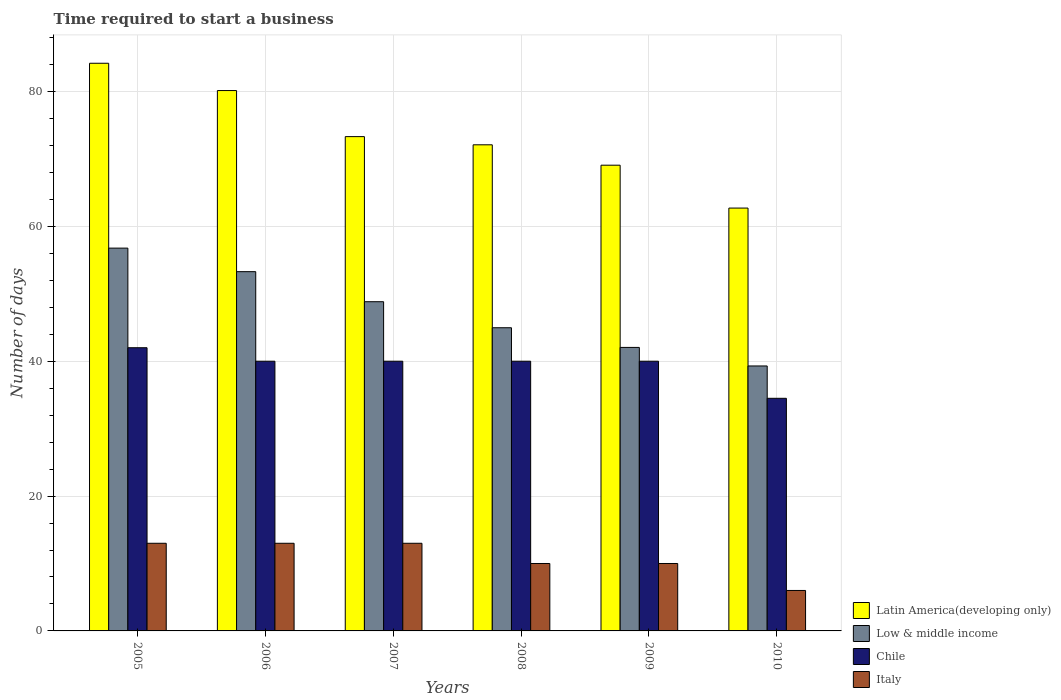Are the number of bars on each tick of the X-axis equal?
Provide a short and direct response. Yes. How many bars are there on the 3rd tick from the left?
Keep it short and to the point. 4. How many bars are there on the 3rd tick from the right?
Give a very brief answer. 4. What is the number of days required to start a business in Latin America(developing only) in 2010?
Offer a terse response. 62.71. Across all years, what is the maximum number of days required to start a business in Low & middle income?
Offer a very short reply. 56.77. Across all years, what is the minimum number of days required to start a business in Latin America(developing only)?
Your answer should be very brief. 62.71. In which year was the number of days required to start a business in Italy maximum?
Give a very brief answer. 2005. What is the total number of days required to start a business in Low & middle income in the graph?
Provide a short and direct response. 285.19. What is the difference between the number of days required to start a business in Low & middle income in 2005 and that in 2010?
Ensure brevity in your answer.  17.48. What is the difference between the number of days required to start a business in Italy in 2007 and the number of days required to start a business in Latin America(developing only) in 2010?
Make the answer very short. -49.71. What is the average number of days required to start a business in Italy per year?
Offer a terse response. 10.83. In the year 2006, what is the difference between the number of days required to start a business in Latin America(developing only) and number of days required to start a business in Low & middle income?
Your response must be concise. 26.86. What is the ratio of the number of days required to start a business in Chile in 2006 to that in 2009?
Make the answer very short. 1. Is the number of days required to start a business in Latin America(developing only) in 2007 less than that in 2009?
Give a very brief answer. No. What is the difference between the highest and the second highest number of days required to start a business in Chile?
Make the answer very short. 2. Is the sum of the number of days required to start a business in Chile in 2009 and 2010 greater than the maximum number of days required to start a business in Low & middle income across all years?
Ensure brevity in your answer.  Yes. Is it the case that in every year, the sum of the number of days required to start a business in Latin America(developing only) and number of days required to start a business in Low & middle income is greater than the sum of number of days required to start a business in Italy and number of days required to start a business in Chile?
Keep it short and to the point. Yes. What does the 3rd bar from the left in 2005 represents?
Offer a terse response. Chile. Is it the case that in every year, the sum of the number of days required to start a business in Chile and number of days required to start a business in Low & middle income is greater than the number of days required to start a business in Italy?
Provide a succinct answer. Yes. How many bars are there?
Provide a short and direct response. 24. Are all the bars in the graph horizontal?
Your answer should be compact. No. How many years are there in the graph?
Keep it short and to the point. 6. Where does the legend appear in the graph?
Provide a short and direct response. Bottom right. What is the title of the graph?
Give a very brief answer. Time required to start a business. Does "Malta" appear as one of the legend labels in the graph?
Keep it short and to the point. No. What is the label or title of the Y-axis?
Give a very brief answer. Number of days. What is the Number of days in Latin America(developing only) in 2005?
Ensure brevity in your answer.  84.19. What is the Number of days of Low & middle income in 2005?
Make the answer very short. 56.77. What is the Number of days in Italy in 2005?
Your response must be concise. 13. What is the Number of days in Latin America(developing only) in 2006?
Your answer should be very brief. 80.14. What is the Number of days of Low & middle income in 2006?
Make the answer very short. 53.28. What is the Number of days of Chile in 2006?
Your answer should be compact. 40. What is the Number of days of Latin America(developing only) in 2007?
Offer a very short reply. 73.31. What is the Number of days of Low & middle income in 2007?
Your answer should be compact. 48.82. What is the Number of days of Italy in 2007?
Ensure brevity in your answer.  13. What is the Number of days of Latin America(developing only) in 2008?
Your answer should be very brief. 72.1. What is the Number of days of Low & middle income in 2008?
Offer a very short reply. 44.97. What is the Number of days in Italy in 2008?
Your response must be concise. 10. What is the Number of days in Latin America(developing only) in 2009?
Keep it short and to the point. 69.07. What is the Number of days in Low & middle income in 2009?
Offer a very short reply. 42.05. What is the Number of days of Italy in 2009?
Provide a succinct answer. 10. What is the Number of days in Latin America(developing only) in 2010?
Offer a terse response. 62.71. What is the Number of days in Low & middle income in 2010?
Offer a terse response. 39.3. What is the Number of days of Chile in 2010?
Provide a short and direct response. 34.5. Across all years, what is the maximum Number of days in Latin America(developing only)?
Keep it short and to the point. 84.19. Across all years, what is the maximum Number of days in Low & middle income?
Your answer should be compact. 56.77. Across all years, what is the maximum Number of days of Chile?
Provide a short and direct response. 42. Across all years, what is the minimum Number of days of Latin America(developing only)?
Offer a very short reply. 62.71. Across all years, what is the minimum Number of days of Low & middle income?
Your response must be concise. 39.3. Across all years, what is the minimum Number of days in Chile?
Give a very brief answer. 34.5. What is the total Number of days in Latin America(developing only) in the graph?
Your response must be concise. 441.52. What is the total Number of days in Low & middle income in the graph?
Your answer should be compact. 285.19. What is the total Number of days in Chile in the graph?
Your response must be concise. 236.5. What is the difference between the Number of days of Latin America(developing only) in 2005 and that in 2006?
Your answer should be very brief. 4.05. What is the difference between the Number of days of Low & middle income in 2005 and that in 2006?
Provide a succinct answer. 3.49. What is the difference between the Number of days in Chile in 2005 and that in 2006?
Ensure brevity in your answer.  2. What is the difference between the Number of days of Italy in 2005 and that in 2006?
Offer a very short reply. 0. What is the difference between the Number of days in Latin America(developing only) in 2005 and that in 2007?
Keep it short and to the point. 10.88. What is the difference between the Number of days in Low & middle income in 2005 and that in 2007?
Make the answer very short. 7.95. What is the difference between the Number of days of Italy in 2005 and that in 2007?
Offer a terse response. 0. What is the difference between the Number of days in Latin America(developing only) in 2005 and that in 2008?
Provide a succinct answer. 12.1. What is the difference between the Number of days in Low & middle income in 2005 and that in 2008?
Make the answer very short. 11.81. What is the difference between the Number of days of Italy in 2005 and that in 2008?
Provide a short and direct response. 3. What is the difference between the Number of days of Latin America(developing only) in 2005 and that in 2009?
Make the answer very short. 15.12. What is the difference between the Number of days of Low & middle income in 2005 and that in 2009?
Your response must be concise. 14.73. What is the difference between the Number of days of Chile in 2005 and that in 2009?
Provide a short and direct response. 2. What is the difference between the Number of days of Italy in 2005 and that in 2009?
Provide a short and direct response. 3. What is the difference between the Number of days in Latin America(developing only) in 2005 and that in 2010?
Give a very brief answer. 21.48. What is the difference between the Number of days in Low & middle income in 2005 and that in 2010?
Offer a very short reply. 17.48. What is the difference between the Number of days of Italy in 2005 and that in 2010?
Provide a succinct answer. 7. What is the difference between the Number of days in Latin America(developing only) in 2006 and that in 2007?
Offer a terse response. 6.83. What is the difference between the Number of days of Low & middle income in 2006 and that in 2007?
Ensure brevity in your answer.  4.46. What is the difference between the Number of days in Chile in 2006 and that in 2007?
Your response must be concise. 0. What is the difference between the Number of days in Italy in 2006 and that in 2007?
Keep it short and to the point. 0. What is the difference between the Number of days in Latin America(developing only) in 2006 and that in 2008?
Offer a terse response. 8.05. What is the difference between the Number of days in Low & middle income in 2006 and that in 2008?
Make the answer very short. 8.32. What is the difference between the Number of days of Chile in 2006 and that in 2008?
Provide a succinct answer. 0. What is the difference between the Number of days of Latin America(developing only) in 2006 and that in 2009?
Make the answer very short. 11.07. What is the difference between the Number of days of Low & middle income in 2006 and that in 2009?
Provide a short and direct response. 11.24. What is the difference between the Number of days in Chile in 2006 and that in 2009?
Your answer should be compact. 0. What is the difference between the Number of days of Latin America(developing only) in 2006 and that in 2010?
Provide a short and direct response. 17.43. What is the difference between the Number of days in Low & middle income in 2006 and that in 2010?
Give a very brief answer. 13.99. What is the difference between the Number of days in Chile in 2006 and that in 2010?
Make the answer very short. 5.5. What is the difference between the Number of days in Italy in 2006 and that in 2010?
Your response must be concise. 7. What is the difference between the Number of days in Latin America(developing only) in 2007 and that in 2008?
Provide a succinct answer. 1.21. What is the difference between the Number of days of Low & middle income in 2007 and that in 2008?
Your answer should be very brief. 3.86. What is the difference between the Number of days of Italy in 2007 and that in 2008?
Your answer should be compact. 3. What is the difference between the Number of days of Latin America(developing only) in 2007 and that in 2009?
Your response must be concise. 4.24. What is the difference between the Number of days in Low & middle income in 2007 and that in 2009?
Ensure brevity in your answer.  6.78. What is the difference between the Number of days of Chile in 2007 and that in 2009?
Provide a succinct answer. 0. What is the difference between the Number of days of Italy in 2007 and that in 2009?
Offer a terse response. 3. What is the difference between the Number of days in Latin America(developing only) in 2007 and that in 2010?
Offer a very short reply. 10.6. What is the difference between the Number of days of Low & middle income in 2007 and that in 2010?
Your answer should be compact. 9.53. What is the difference between the Number of days of Italy in 2007 and that in 2010?
Your answer should be very brief. 7. What is the difference between the Number of days in Latin America(developing only) in 2008 and that in 2009?
Your response must be concise. 3.02. What is the difference between the Number of days of Low & middle income in 2008 and that in 2009?
Your response must be concise. 2.92. What is the difference between the Number of days of Latin America(developing only) in 2008 and that in 2010?
Your answer should be compact. 9.38. What is the difference between the Number of days in Low & middle income in 2008 and that in 2010?
Offer a very short reply. 5.67. What is the difference between the Number of days of Italy in 2008 and that in 2010?
Offer a very short reply. 4. What is the difference between the Number of days of Latin America(developing only) in 2009 and that in 2010?
Make the answer very short. 6.36. What is the difference between the Number of days of Low & middle income in 2009 and that in 2010?
Offer a very short reply. 2.75. What is the difference between the Number of days in Chile in 2009 and that in 2010?
Provide a succinct answer. 5.5. What is the difference between the Number of days of Latin America(developing only) in 2005 and the Number of days of Low & middle income in 2006?
Your answer should be very brief. 30.91. What is the difference between the Number of days of Latin America(developing only) in 2005 and the Number of days of Chile in 2006?
Keep it short and to the point. 44.19. What is the difference between the Number of days of Latin America(developing only) in 2005 and the Number of days of Italy in 2006?
Your answer should be compact. 71.19. What is the difference between the Number of days in Low & middle income in 2005 and the Number of days in Chile in 2006?
Your answer should be compact. 16.77. What is the difference between the Number of days in Low & middle income in 2005 and the Number of days in Italy in 2006?
Your response must be concise. 43.77. What is the difference between the Number of days in Chile in 2005 and the Number of days in Italy in 2006?
Your response must be concise. 29. What is the difference between the Number of days of Latin America(developing only) in 2005 and the Number of days of Low & middle income in 2007?
Keep it short and to the point. 35.37. What is the difference between the Number of days in Latin America(developing only) in 2005 and the Number of days in Chile in 2007?
Provide a succinct answer. 44.19. What is the difference between the Number of days of Latin America(developing only) in 2005 and the Number of days of Italy in 2007?
Make the answer very short. 71.19. What is the difference between the Number of days in Low & middle income in 2005 and the Number of days in Chile in 2007?
Offer a terse response. 16.77. What is the difference between the Number of days in Low & middle income in 2005 and the Number of days in Italy in 2007?
Offer a very short reply. 43.77. What is the difference between the Number of days of Chile in 2005 and the Number of days of Italy in 2007?
Offer a terse response. 29. What is the difference between the Number of days in Latin America(developing only) in 2005 and the Number of days in Low & middle income in 2008?
Your answer should be very brief. 39.22. What is the difference between the Number of days in Latin America(developing only) in 2005 and the Number of days in Chile in 2008?
Offer a very short reply. 44.19. What is the difference between the Number of days in Latin America(developing only) in 2005 and the Number of days in Italy in 2008?
Keep it short and to the point. 74.19. What is the difference between the Number of days in Low & middle income in 2005 and the Number of days in Chile in 2008?
Give a very brief answer. 16.77. What is the difference between the Number of days of Low & middle income in 2005 and the Number of days of Italy in 2008?
Your answer should be compact. 46.77. What is the difference between the Number of days in Latin America(developing only) in 2005 and the Number of days in Low & middle income in 2009?
Your answer should be compact. 42.14. What is the difference between the Number of days in Latin America(developing only) in 2005 and the Number of days in Chile in 2009?
Provide a short and direct response. 44.19. What is the difference between the Number of days in Latin America(developing only) in 2005 and the Number of days in Italy in 2009?
Give a very brief answer. 74.19. What is the difference between the Number of days of Low & middle income in 2005 and the Number of days of Chile in 2009?
Your answer should be compact. 16.77. What is the difference between the Number of days of Low & middle income in 2005 and the Number of days of Italy in 2009?
Your answer should be compact. 46.77. What is the difference between the Number of days of Latin America(developing only) in 2005 and the Number of days of Low & middle income in 2010?
Make the answer very short. 44.89. What is the difference between the Number of days of Latin America(developing only) in 2005 and the Number of days of Chile in 2010?
Your answer should be compact. 49.69. What is the difference between the Number of days in Latin America(developing only) in 2005 and the Number of days in Italy in 2010?
Offer a very short reply. 78.19. What is the difference between the Number of days in Low & middle income in 2005 and the Number of days in Chile in 2010?
Make the answer very short. 22.27. What is the difference between the Number of days of Low & middle income in 2005 and the Number of days of Italy in 2010?
Your answer should be very brief. 50.77. What is the difference between the Number of days in Chile in 2005 and the Number of days in Italy in 2010?
Offer a terse response. 36. What is the difference between the Number of days in Latin America(developing only) in 2006 and the Number of days in Low & middle income in 2007?
Offer a very short reply. 31.32. What is the difference between the Number of days in Latin America(developing only) in 2006 and the Number of days in Chile in 2007?
Ensure brevity in your answer.  40.14. What is the difference between the Number of days in Latin America(developing only) in 2006 and the Number of days in Italy in 2007?
Offer a terse response. 67.14. What is the difference between the Number of days in Low & middle income in 2006 and the Number of days in Chile in 2007?
Offer a very short reply. 13.28. What is the difference between the Number of days of Low & middle income in 2006 and the Number of days of Italy in 2007?
Provide a short and direct response. 40.28. What is the difference between the Number of days in Latin America(developing only) in 2006 and the Number of days in Low & middle income in 2008?
Your response must be concise. 35.18. What is the difference between the Number of days in Latin America(developing only) in 2006 and the Number of days in Chile in 2008?
Give a very brief answer. 40.14. What is the difference between the Number of days of Latin America(developing only) in 2006 and the Number of days of Italy in 2008?
Give a very brief answer. 70.14. What is the difference between the Number of days in Low & middle income in 2006 and the Number of days in Chile in 2008?
Provide a short and direct response. 13.28. What is the difference between the Number of days of Low & middle income in 2006 and the Number of days of Italy in 2008?
Provide a succinct answer. 43.28. What is the difference between the Number of days of Latin America(developing only) in 2006 and the Number of days of Low & middle income in 2009?
Ensure brevity in your answer.  38.1. What is the difference between the Number of days of Latin America(developing only) in 2006 and the Number of days of Chile in 2009?
Provide a succinct answer. 40.14. What is the difference between the Number of days of Latin America(developing only) in 2006 and the Number of days of Italy in 2009?
Your answer should be compact. 70.14. What is the difference between the Number of days in Low & middle income in 2006 and the Number of days in Chile in 2009?
Ensure brevity in your answer.  13.28. What is the difference between the Number of days of Low & middle income in 2006 and the Number of days of Italy in 2009?
Ensure brevity in your answer.  43.28. What is the difference between the Number of days of Chile in 2006 and the Number of days of Italy in 2009?
Offer a terse response. 30. What is the difference between the Number of days in Latin America(developing only) in 2006 and the Number of days in Low & middle income in 2010?
Provide a succinct answer. 40.85. What is the difference between the Number of days in Latin America(developing only) in 2006 and the Number of days in Chile in 2010?
Give a very brief answer. 45.64. What is the difference between the Number of days of Latin America(developing only) in 2006 and the Number of days of Italy in 2010?
Make the answer very short. 74.14. What is the difference between the Number of days in Low & middle income in 2006 and the Number of days in Chile in 2010?
Offer a terse response. 18.78. What is the difference between the Number of days of Low & middle income in 2006 and the Number of days of Italy in 2010?
Offer a terse response. 47.28. What is the difference between the Number of days in Latin America(developing only) in 2007 and the Number of days in Low & middle income in 2008?
Offer a very short reply. 28.34. What is the difference between the Number of days of Latin America(developing only) in 2007 and the Number of days of Chile in 2008?
Provide a succinct answer. 33.31. What is the difference between the Number of days of Latin America(developing only) in 2007 and the Number of days of Italy in 2008?
Keep it short and to the point. 63.31. What is the difference between the Number of days in Low & middle income in 2007 and the Number of days in Chile in 2008?
Keep it short and to the point. 8.82. What is the difference between the Number of days of Low & middle income in 2007 and the Number of days of Italy in 2008?
Your answer should be very brief. 38.82. What is the difference between the Number of days in Latin America(developing only) in 2007 and the Number of days in Low & middle income in 2009?
Your answer should be compact. 31.26. What is the difference between the Number of days of Latin America(developing only) in 2007 and the Number of days of Chile in 2009?
Provide a short and direct response. 33.31. What is the difference between the Number of days of Latin America(developing only) in 2007 and the Number of days of Italy in 2009?
Your response must be concise. 63.31. What is the difference between the Number of days in Low & middle income in 2007 and the Number of days in Chile in 2009?
Offer a terse response. 8.82. What is the difference between the Number of days in Low & middle income in 2007 and the Number of days in Italy in 2009?
Your response must be concise. 38.82. What is the difference between the Number of days of Chile in 2007 and the Number of days of Italy in 2009?
Your response must be concise. 30. What is the difference between the Number of days of Latin America(developing only) in 2007 and the Number of days of Low & middle income in 2010?
Your response must be concise. 34.01. What is the difference between the Number of days of Latin America(developing only) in 2007 and the Number of days of Chile in 2010?
Make the answer very short. 38.81. What is the difference between the Number of days of Latin America(developing only) in 2007 and the Number of days of Italy in 2010?
Provide a short and direct response. 67.31. What is the difference between the Number of days of Low & middle income in 2007 and the Number of days of Chile in 2010?
Your answer should be compact. 14.32. What is the difference between the Number of days in Low & middle income in 2007 and the Number of days in Italy in 2010?
Make the answer very short. 42.82. What is the difference between the Number of days of Latin America(developing only) in 2008 and the Number of days of Low & middle income in 2009?
Make the answer very short. 30.05. What is the difference between the Number of days of Latin America(developing only) in 2008 and the Number of days of Chile in 2009?
Your answer should be compact. 32.1. What is the difference between the Number of days in Latin America(developing only) in 2008 and the Number of days in Italy in 2009?
Your response must be concise. 62.1. What is the difference between the Number of days in Low & middle income in 2008 and the Number of days in Chile in 2009?
Ensure brevity in your answer.  4.97. What is the difference between the Number of days of Low & middle income in 2008 and the Number of days of Italy in 2009?
Make the answer very short. 34.97. What is the difference between the Number of days of Chile in 2008 and the Number of days of Italy in 2009?
Your answer should be compact. 30. What is the difference between the Number of days in Latin America(developing only) in 2008 and the Number of days in Low & middle income in 2010?
Give a very brief answer. 32.8. What is the difference between the Number of days in Latin America(developing only) in 2008 and the Number of days in Chile in 2010?
Offer a very short reply. 37.6. What is the difference between the Number of days in Latin America(developing only) in 2008 and the Number of days in Italy in 2010?
Provide a succinct answer. 66.1. What is the difference between the Number of days of Low & middle income in 2008 and the Number of days of Chile in 2010?
Your response must be concise. 10.47. What is the difference between the Number of days of Low & middle income in 2008 and the Number of days of Italy in 2010?
Ensure brevity in your answer.  38.97. What is the difference between the Number of days in Latin America(developing only) in 2009 and the Number of days in Low & middle income in 2010?
Give a very brief answer. 29.77. What is the difference between the Number of days in Latin America(developing only) in 2009 and the Number of days in Chile in 2010?
Ensure brevity in your answer.  34.57. What is the difference between the Number of days of Latin America(developing only) in 2009 and the Number of days of Italy in 2010?
Give a very brief answer. 63.07. What is the difference between the Number of days in Low & middle income in 2009 and the Number of days in Chile in 2010?
Provide a short and direct response. 7.55. What is the difference between the Number of days of Low & middle income in 2009 and the Number of days of Italy in 2010?
Offer a terse response. 36.05. What is the difference between the Number of days in Chile in 2009 and the Number of days in Italy in 2010?
Make the answer very short. 34. What is the average Number of days of Latin America(developing only) per year?
Your answer should be compact. 73.59. What is the average Number of days of Low & middle income per year?
Your response must be concise. 47.53. What is the average Number of days in Chile per year?
Provide a short and direct response. 39.42. What is the average Number of days of Italy per year?
Provide a short and direct response. 10.83. In the year 2005, what is the difference between the Number of days of Latin America(developing only) and Number of days of Low & middle income?
Your response must be concise. 27.42. In the year 2005, what is the difference between the Number of days in Latin America(developing only) and Number of days in Chile?
Offer a very short reply. 42.19. In the year 2005, what is the difference between the Number of days of Latin America(developing only) and Number of days of Italy?
Offer a terse response. 71.19. In the year 2005, what is the difference between the Number of days of Low & middle income and Number of days of Chile?
Provide a succinct answer. 14.77. In the year 2005, what is the difference between the Number of days in Low & middle income and Number of days in Italy?
Provide a short and direct response. 43.77. In the year 2005, what is the difference between the Number of days in Chile and Number of days in Italy?
Keep it short and to the point. 29. In the year 2006, what is the difference between the Number of days of Latin America(developing only) and Number of days of Low & middle income?
Your answer should be compact. 26.86. In the year 2006, what is the difference between the Number of days of Latin America(developing only) and Number of days of Chile?
Your answer should be very brief. 40.14. In the year 2006, what is the difference between the Number of days of Latin America(developing only) and Number of days of Italy?
Make the answer very short. 67.14. In the year 2006, what is the difference between the Number of days in Low & middle income and Number of days in Chile?
Make the answer very short. 13.28. In the year 2006, what is the difference between the Number of days in Low & middle income and Number of days in Italy?
Offer a very short reply. 40.28. In the year 2007, what is the difference between the Number of days of Latin America(developing only) and Number of days of Low & middle income?
Keep it short and to the point. 24.48. In the year 2007, what is the difference between the Number of days of Latin America(developing only) and Number of days of Chile?
Keep it short and to the point. 33.31. In the year 2007, what is the difference between the Number of days in Latin America(developing only) and Number of days in Italy?
Ensure brevity in your answer.  60.31. In the year 2007, what is the difference between the Number of days in Low & middle income and Number of days in Chile?
Offer a terse response. 8.82. In the year 2007, what is the difference between the Number of days of Low & middle income and Number of days of Italy?
Offer a very short reply. 35.82. In the year 2008, what is the difference between the Number of days of Latin America(developing only) and Number of days of Low & middle income?
Your answer should be very brief. 27.13. In the year 2008, what is the difference between the Number of days in Latin America(developing only) and Number of days in Chile?
Keep it short and to the point. 32.1. In the year 2008, what is the difference between the Number of days of Latin America(developing only) and Number of days of Italy?
Offer a very short reply. 62.1. In the year 2008, what is the difference between the Number of days in Low & middle income and Number of days in Chile?
Offer a terse response. 4.97. In the year 2008, what is the difference between the Number of days in Low & middle income and Number of days in Italy?
Ensure brevity in your answer.  34.97. In the year 2008, what is the difference between the Number of days of Chile and Number of days of Italy?
Give a very brief answer. 30. In the year 2009, what is the difference between the Number of days of Latin America(developing only) and Number of days of Low & middle income?
Ensure brevity in your answer.  27.02. In the year 2009, what is the difference between the Number of days in Latin America(developing only) and Number of days in Chile?
Make the answer very short. 29.07. In the year 2009, what is the difference between the Number of days of Latin America(developing only) and Number of days of Italy?
Give a very brief answer. 59.07. In the year 2009, what is the difference between the Number of days of Low & middle income and Number of days of Chile?
Keep it short and to the point. 2.05. In the year 2009, what is the difference between the Number of days of Low & middle income and Number of days of Italy?
Provide a succinct answer. 32.05. In the year 2009, what is the difference between the Number of days of Chile and Number of days of Italy?
Give a very brief answer. 30. In the year 2010, what is the difference between the Number of days of Latin America(developing only) and Number of days of Low & middle income?
Your answer should be very brief. 23.42. In the year 2010, what is the difference between the Number of days in Latin America(developing only) and Number of days in Chile?
Make the answer very short. 28.21. In the year 2010, what is the difference between the Number of days of Latin America(developing only) and Number of days of Italy?
Provide a succinct answer. 56.71. In the year 2010, what is the difference between the Number of days in Low & middle income and Number of days in Chile?
Your answer should be compact. 4.8. In the year 2010, what is the difference between the Number of days of Low & middle income and Number of days of Italy?
Offer a terse response. 33.3. What is the ratio of the Number of days in Latin America(developing only) in 2005 to that in 2006?
Your answer should be very brief. 1.05. What is the ratio of the Number of days in Low & middle income in 2005 to that in 2006?
Offer a very short reply. 1.07. What is the ratio of the Number of days of Chile in 2005 to that in 2006?
Provide a short and direct response. 1.05. What is the ratio of the Number of days in Latin America(developing only) in 2005 to that in 2007?
Your answer should be compact. 1.15. What is the ratio of the Number of days in Low & middle income in 2005 to that in 2007?
Your response must be concise. 1.16. What is the ratio of the Number of days in Chile in 2005 to that in 2007?
Offer a very short reply. 1.05. What is the ratio of the Number of days in Italy in 2005 to that in 2007?
Offer a terse response. 1. What is the ratio of the Number of days of Latin America(developing only) in 2005 to that in 2008?
Give a very brief answer. 1.17. What is the ratio of the Number of days in Low & middle income in 2005 to that in 2008?
Your answer should be compact. 1.26. What is the ratio of the Number of days in Chile in 2005 to that in 2008?
Provide a succinct answer. 1.05. What is the ratio of the Number of days of Latin America(developing only) in 2005 to that in 2009?
Provide a short and direct response. 1.22. What is the ratio of the Number of days of Low & middle income in 2005 to that in 2009?
Offer a terse response. 1.35. What is the ratio of the Number of days of Italy in 2005 to that in 2009?
Provide a succinct answer. 1.3. What is the ratio of the Number of days in Latin America(developing only) in 2005 to that in 2010?
Your answer should be very brief. 1.34. What is the ratio of the Number of days of Low & middle income in 2005 to that in 2010?
Offer a terse response. 1.44. What is the ratio of the Number of days in Chile in 2005 to that in 2010?
Make the answer very short. 1.22. What is the ratio of the Number of days in Italy in 2005 to that in 2010?
Provide a short and direct response. 2.17. What is the ratio of the Number of days in Latin America(developing only) in 2006 to that in 2007?
Provide a short and direct response. 1.09. What is the ratio of the Number of days of Low & middle income in 2006 to that in 2007?
Your response must be concise. 1.09. What is the ratio of the Number of days of Chile in 2006 to that in 2007?
Your answer should be very brief. 1. What is the ratio of the Number of days in Italy in 2006 to that in 2007?
Make the answer very short. 1. What is the ratio of the Number of days of Latin America(developing only) in 2006 to that in 2008?
Offer a terse response. 1.11. What is the ratio of the Number of days of Low & middle income in 2006 to that in 2008?
Provide a short and direct response. 1.18. What is the ratio of the Number of days in Chile in 2006 to that in 2008?
Provide a short and direct response. 1. What is the ratio of the Number of days in Italy in 2006 to that in 2008?
Your response must be concise. 1.3. What is the ratio of the Number of days of Latin America(developing only) in 2006 to that in 2009?
Ensure brevity in your answer.  1.16. What is the ratio of the Number of days in Low & middle income in 2006 to that in 2009?
Ensure brevity in your answer.  1.27. What is the ratio of the Number of days in Chile in 2006 to that in 2009?
Offer a terse response. 1. What is the ratio of the Number of days of Latin America(developing only) in 2006 to that in 2010?
Make the answer very short. 1.28. What is the ratio of the Number of days of Low & middle income in 2006 to that in 2010?
Make the answer very short. 1.36. What is the ratio of the Number of days in Chile in 2006 to that in 2010?
Your answer should be compact. 1.16. What is the ratio of the Number of days of Italy in 2006 to that in 2010?
Give a very brief answer. 2.17. What is the ratio of the Number of days in Latin America(developing only) in 2007 to that in 2008?
Provide a succinct answer. 1.02. What is the ratio of the Number of days in Low & middle income in 2007 to that in 2008?
Offer a terse response. 1.09. What is the ratio of the Number of days in Italy in 2007 to that in 2008?
Make the answer very short. 1.3. What is the ratio of the Number of days of Latin America(developing only) in 2007 to that in 2009?
Offer a terse response. 1.06. What is the ratio of the Number of days of Low & middle income in 2007 to that in 2009?
Your answer should be compact. 1.16. What is the ratio of the Number of days of Latin America(developing only) in 2007 to that in 2010?
Ensure brevity in your answer.  1.17. What is the ratio of the Number of days of Low & middle income in 2007 to that in 2010?
Keep it short and to the point. 1.24. What is the ratio of the Number of days of Chile in 2007 to that in 2010?
Offer a very short reply. 1.16. What is the ratio of the Number of days of Italy in 2007 to that in 2010?
Offer a very short reply. 2.17. What is the ratio of the Number of days in Latin America(developing only) in 2008 to that in 2009?
Give a very brief answer. 1.04. What is the ratio of the Number of days of Low & middle income in 2008 to that in 2009?
Offer a terse response. 1.07. What is the ratio of the Number of days of Italy in 2008 to that in 2009?
Ensure brevity in your answer.  1. What is the ratio of the Number of days of Latin America(developing only) in 2008 to that in 2010?
Your answer should be compact. 1.15. What is the ratio of the Number of days in Low & middle income in 2008 to that in 2010?
Give a very brief answer. 1.14. What is the ratio of the Number of days in Chile in 2008 to that in 2010?
Provide a short and direct response. 1.16. What is the ratio of the Number of days of Latin America(developing only) in 2009 to that in 2010?
Your answer should be very brief. 1.1. What is the ratio of the Number of days of Low & middle income in 2009 to that in 2010?
Your response must be concise. 1.07. What is the ratio of the Number of days of Chile in 2009 to that in 2010?
Make the answer very short. 1.16. What is the ratio of the Number of days of Italy in 2009 to that in 2010?
Your answer should be very brief. 1.67. What is the difference between the highest and the second highest Number of days of Latin America(developing only)?
Ensure brevity in your answer.  4.05. What is the difference between the highest and the second highest Number of days in Low & middle income?
Provide a succinct answer. 3.49. What is the difference between the highest and the second highest Number of days of Chile?
Give a very brief answer. 2. What is the difference between the highest and the second highest Number of days of Italy?
Your response must be concise. 0. What is the difference between the highest and the lowest Number of days of Latin America(developing only)?
Offer a very short reply. 21.48. What is the difference between the highest and the lowest Number of days in Low & middle income?
Your response must be concise. 17.48. What is the difference between the highest and the lowest Number of days of Chile?
Offer a very short reply. 7.5. 